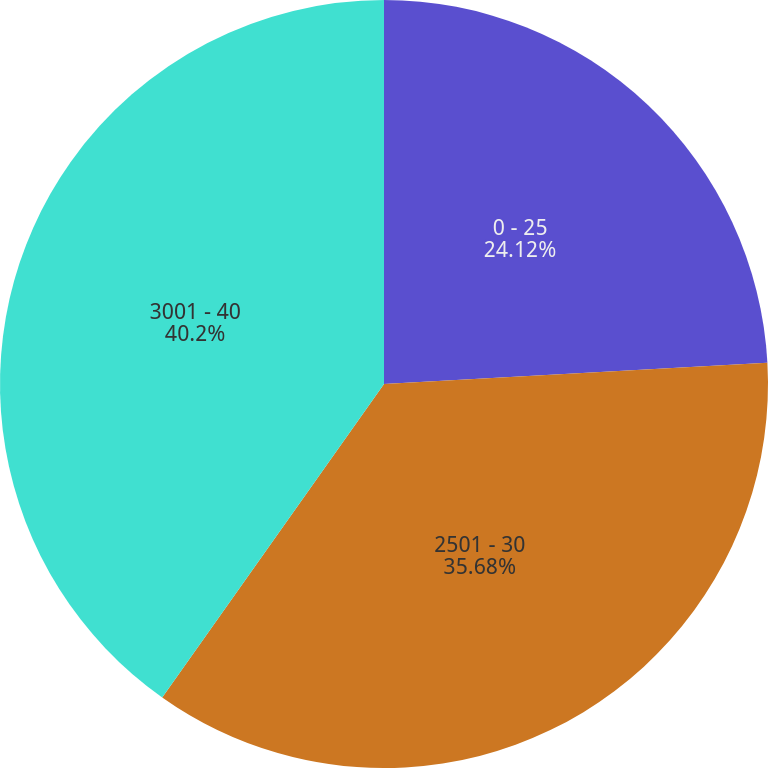Convert chart. <chart><loc_0><loc_0><loc_500><loc_500><pie_chart><fcel>0 - 25<fcel>2501 - 30<fcel>3001 - 40<nl><fcel>24.12%<fcel>35.68%<fcel>40.2%<nl></chart> 